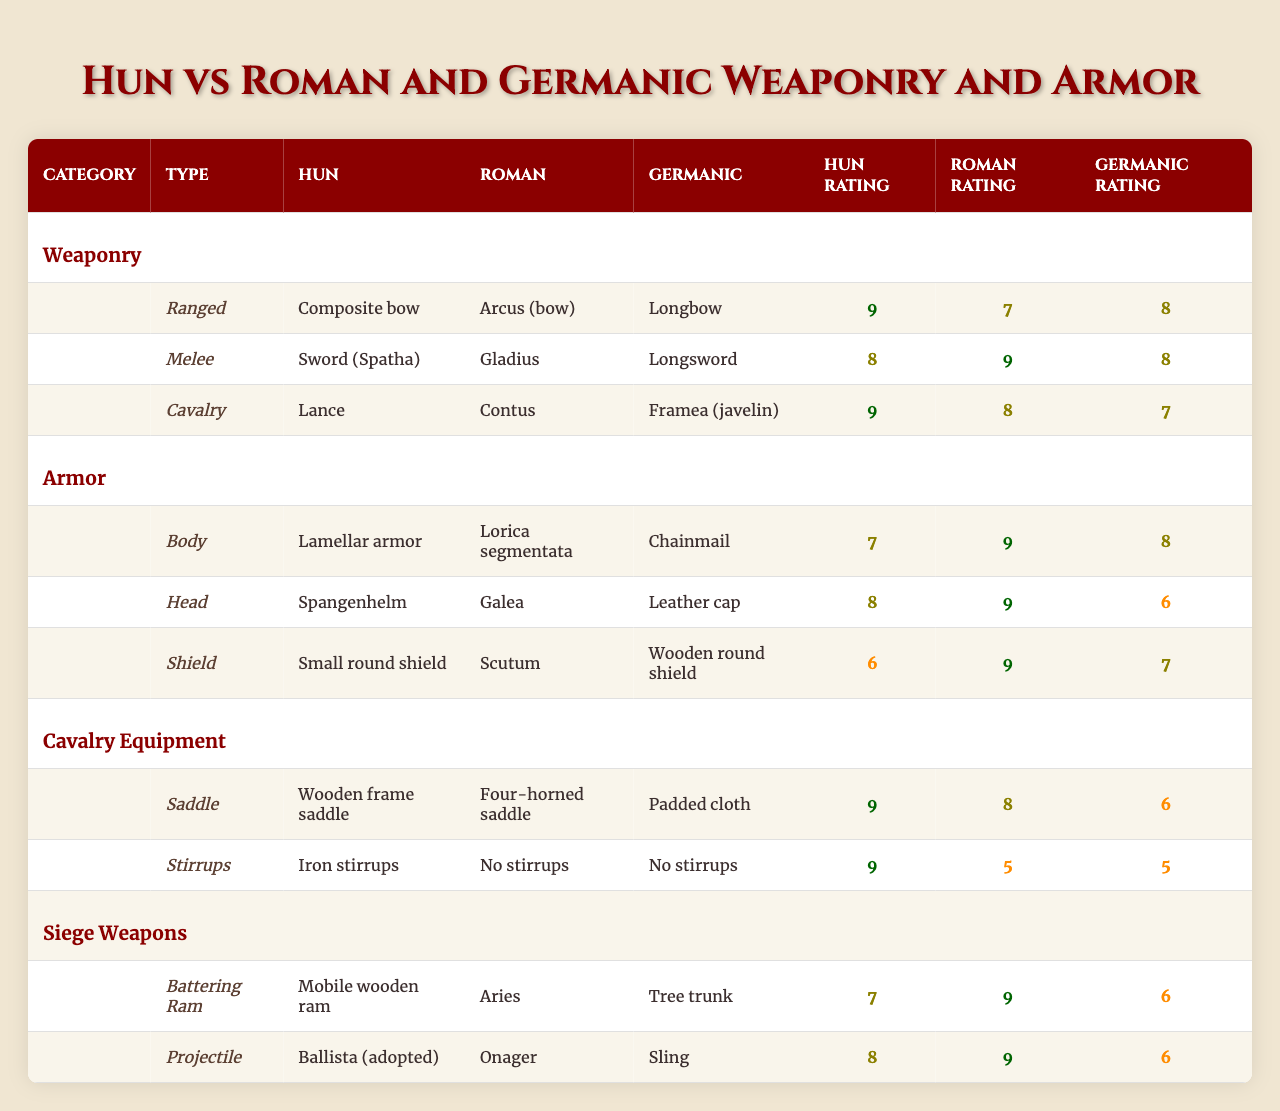What is the effectiveness rating of the Hun's composite bow? The table shows that the effectiveness rating for the Hun's composite bow is 9.
Answer: 9 Which type of armor provides the highest protection level? By comparing the protection levels of body, head, and shield armor, we see that the Roman lorica segmentata has the highest rating at 9.
Answer: Roman lorica segmentata What is the difference in effectiveness between the Hun's lance and the Germanic framea? The Hun's lance has an effectiveness rating of 9, while the Germanic framea has a rating of 7. The difference is 9 - 7 = 2.
Answer: 2 Does the Hun's small round shield have a higher protection level than the Germanic wooden round shield? The protection level for the Hun's small round shield is 6, and for the Germanic wooden round shield, it is 7. Since 6 is less than 7, the answer is no.
Answer: No What is the average effectiveness rating of the Hun's melee and cavalry weaponry? The Hun's melee weapon (sword) has an effectiveness of 8, and the cavalry weapon (lance) has an effectiveness of 9. The average is (8 + 9) / 2 = 8.5.
Answer: 8.5 Which cavalry equipment is rated with the highest effectiveness? The Hun's wooden frame saddle and iron stirrups are both rated 9, which is the highest effectiveness across all cavalry equipment.
Answer: The Hun's saddle and stirrups Is the effectiveness of the Roman gladius higher than that of the Hun's spatha? The table lists the Roman gladius effectiveness at 9 and the Hun's spatha at 8, so yes, the Roman gladius is rated higher.
Answer: Yes What is the total effectiveness rating of Hun weaponry and armor combined? The total effectiveness rating for Hun weaponry (composite bow 9 + sword 8 + lance 9) adds up to 26, and for armor (lamellar armor 7 + spangenhelm 8 + small round shield 6), it totals 21. Combining both gives 26 + 21 = 47.
Answer: 47 What is the minimum protection level among the types of armor listed? The protection levels are 7 for lamellar armor, 8 for spangenhelm, and 6 for the small round shield. The minimum protection level is 6 for the small round shield.
Answer: 6 Which weapon type has the highest effectiveness rating among all three groups? The highest effectiveness rating among all the weapons listed is 9, which is shared by the Hun's composite bow and lance, and the Roman gladius.
Answer: 9 